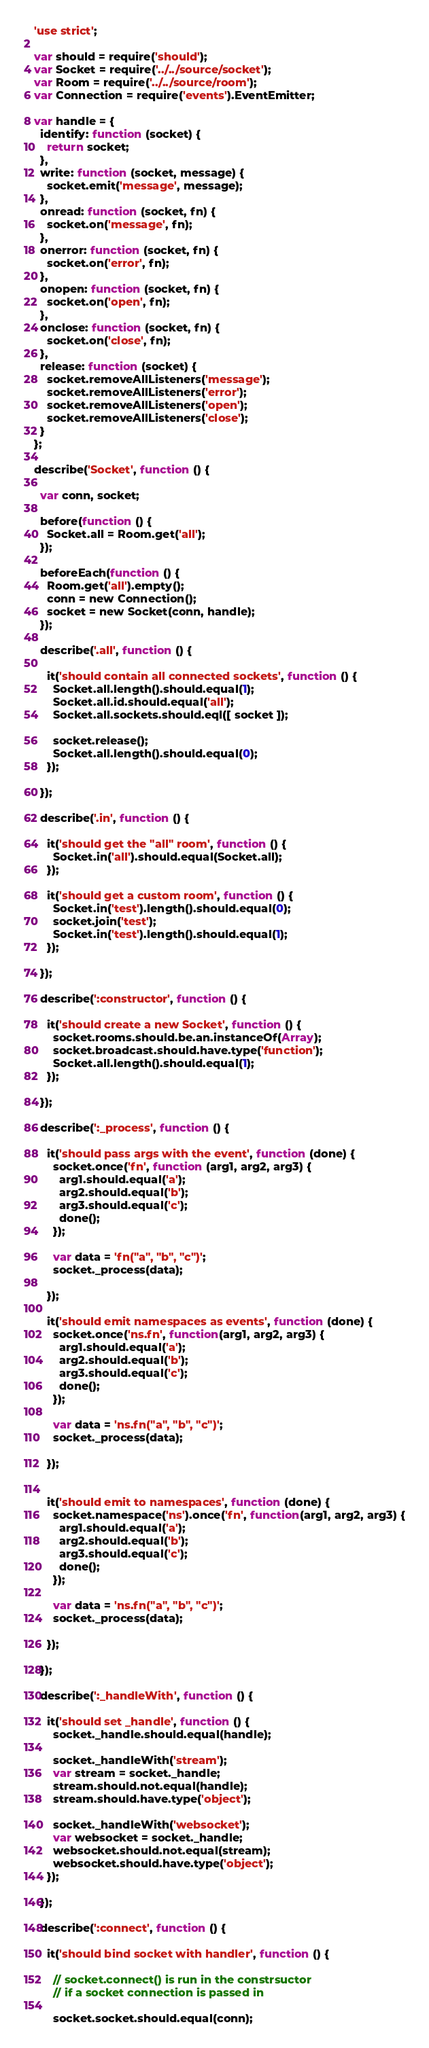<code> <loc_0><loc_0><loc_500><loc_500><_JavaScript_>'use strict';

var should = require('should');
var Socket = require('../../source/socket');
var Room = require('../../source/room');
var Connection = require('events').EventEmitter;

var handle = {
  identify: function (socket) {
    return socket;
  },
  write: function (socket, message) {
    socket.emit('message', message);
  },
  onread: function (socket, fn) {
    socket.on('message', fn);
  },
  onerror: function (socket, fn) {
    socket.on('error', fn);
  },
  onopen: function (socket, fn) {
    socket.on('open', fn);
  },
  onclose: function (socket, fn) {
    socket.on('close', fn);
  },
  release: function (socket) {
    socket.removeAllListeners('message');
    socket.removeAllListeners('error');
    socket.removeAllListeners('open');
    socket.removeAllListeners('close');
  }
};

describe('Socket', function () {

  var conn, socket;

  before(function () {
    Socket.all = Room.get('all');
  });

  beforeEach(function () {
    Room.get('all').empty();
    conn = new Connection();
    socket = new Socket(conn, handle);
  });

  describe('.all', function () {

    it('should contain all connected sockets', function () {
      Socket.all.length().should.equal(1);
      Socket.all.id.should.equal('all');
      Socket.all.sockets.should.eql([ socket ]);

      socket.release();
      Socket.all.length().should.equal(0);
    });

  });

  describe('.in', function () {

    it('should get the "all" room', function () {
      Socket.in('all').should.equal(Socket.all);
    });

    it('should get a custom room', function () {
      Socket.in('test').length().should.equal(0);
      socket.join('test');
      Socket.in('test').length().should.equal(1);
    });

  });

  describe(':constructor', function () {

    it('should create a new Socket', function () {
      socket.rooms.should.be.an.instanceOf(Array);
      socket.broadcast.should.have.type('function');
      Socket.all.length().should.equal(1);
    });

  });

  describe(':_process', function () {

    it('should pass args with the event', function (done) {
      socket.once('fn', function (arg1, arg2, arg3) {
        arg1.should.equal('a');
        arg2.should.equal('b');
        arg3.should.equal('c');
        done();
      });

      var data = 'fn("a", "b", "c")';
      socket._process(data);

    });

    it('should emit namespaces as events', function (done) {
      socket.once('ns.fn', function(arg1, arg2, arg3) {
        arg1.should.equal('a');
        arg2.should.equal('b');
        arg3.should.equal('c');
        done();
      });

      var data = 'ns.fn("a", "b", "c")';
      socket._process(data);

    });


    it('should emit to namespaces', function (done) {
      socket.namespace('ns').once('fn', function(arg1, arg2, arg3) {
        arg1.should.equal('a');
        arg2.should.equal('b');
        arg3.should.equal('c');
        done();
      });

      var data = 'ns.fn("a", "b", "c")';
      socket._process(data);

    });

  });

  describe(':_handleWith', function () {

    it('should set _handle', function () {
      socket._handle.should.equal(handle);

      socket._handleWith('stream');
      var stream = socket._handle;
      stream.should.not.equal(handle);
      stream.should.have.type('object');

      socket._handleWith('websocket');
      var websocket = socket._handle;
      websocket.should.not.equal(stream);
      websocket.should.have.type('object');
    });

  });

  describe(':connect', function () {

    it('should bind socket with handler', function () {

      // socket.connect() is run in the constrsuctor
      // if a socket connection is passed in

      socket.socket.should.equal(conn);</code> 